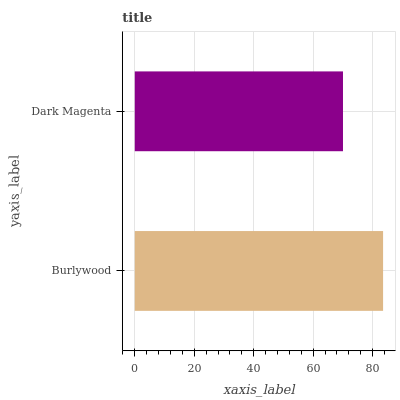Is Dark Magenta the minimum?
Answer yes or no. Yes. Is Burlywood the maximum?
Answer yes or no. Yes. Is Dark Magenta the maximum?
Answer yes or no. No. Is Burlywood greater than Dark Magenta?
Answer yes or no. Yes. Is Dark Magenta less than Burlywood?
Answer yes or no. Yes. Is Dark Magenta greater than Burlywood?
Answer yes or no. No. Is Burlywood less than Dark Magenta?
Answer yes or no. No. Is Burlywood the high median?
Answer yes or no. Yes. Is Dark Magenta the low median?
Answer yes or no. Yes. Is Dark Magenta the high median?
Answer yes or no. No. Is Burlywood the low median?
Answer yes or no. No. 